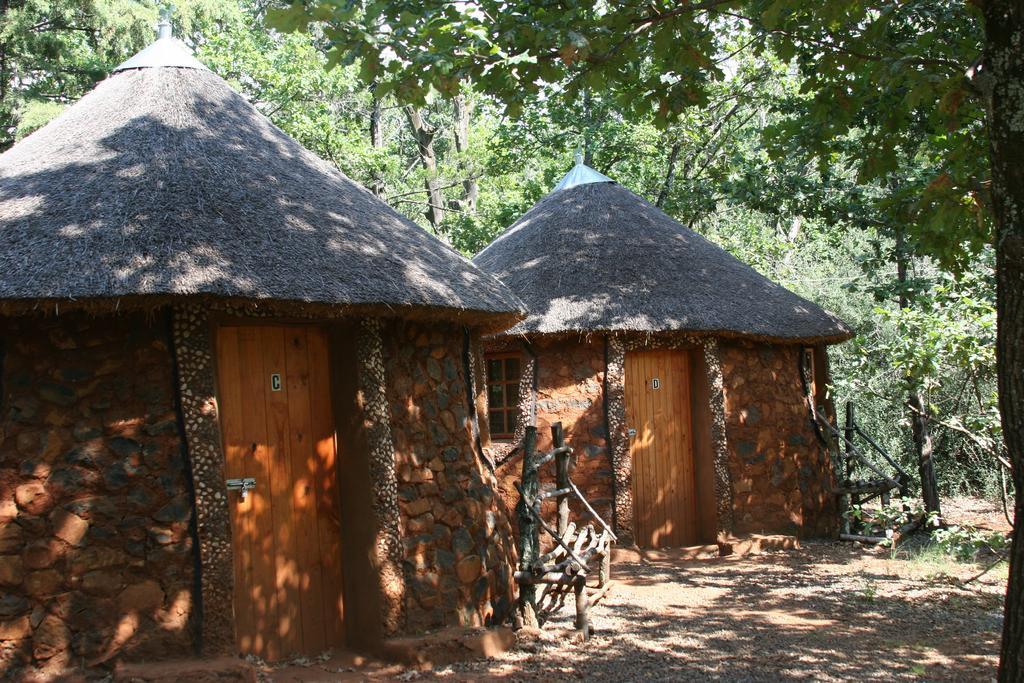How would you summarize this image in a sentence or two? In this image there are huts and trees. 